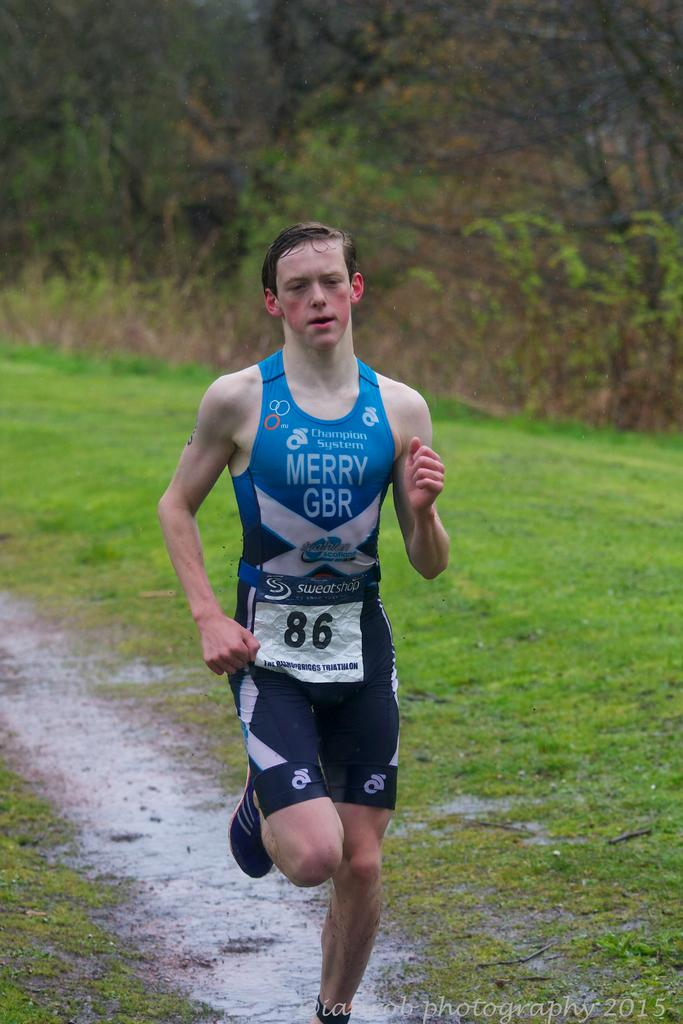<image>
Render a clear and concise summary of the photo. A man with number 86 attached to his Merry GBR jersey is running in a field. 